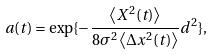Convert formula to latex. <formula><loc_0><loc_0><loc_500><loc_500>a ( t ) = \exp \{ - \frac { \left \langle X ^ { 2 } ( t ) \right \rangle } { 8 \sigma ^ { 2 } \left \langle \Delta x ^ { 2 } ( t ) \right \rangle } d ^ { 2 } \} ,</formula> 